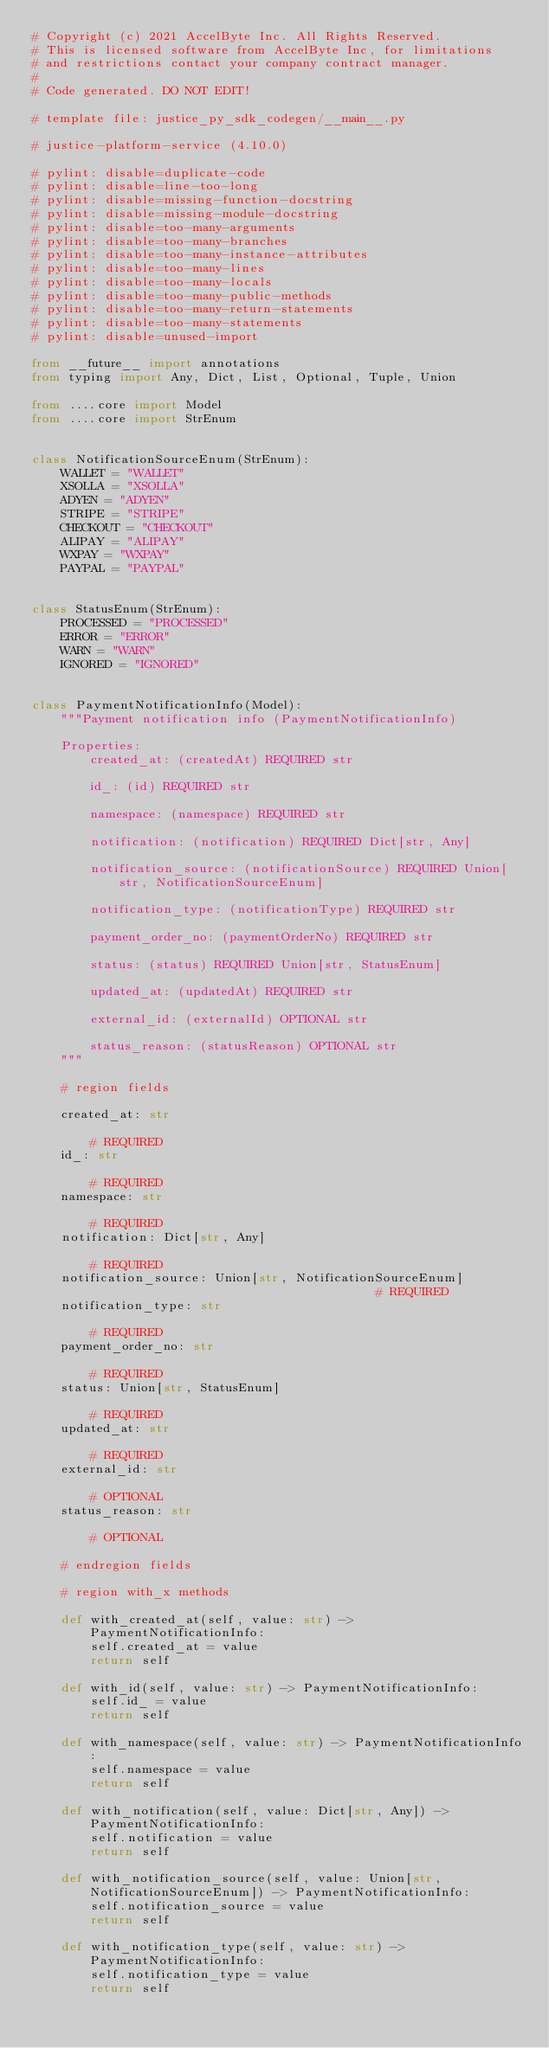Convert code to text. <code><loc_0><loc_0><loc_500><loc_500><_Python_># Copyright (c) 2021 AccelByte Inc. All Rights Reserved.
# This is licensed software from AccelByte Inc, for limitations
# and restrictions contact your company contract manager.
# 
# Code generated. DO NOT EDIT!

# template file: justice_py_sdk_codegen/__main__.py

# justice-platform-service (4.10.0)

# pylint: disable=duplicate-code
# pylint: disable=line-too-long
# pylint: disable=missing-function-docstring
# pylint: disable=missing-module-docstring
# pylint: disable=too-many-arguments
# pylint: disable=too-many-branches
# pylint: disable=too-many-instance-attributes
# pylint: disable=too-many-lines
# pylint: disable=too-many-locals
# pylint: disable=too-many-public-methods
# pylint: disable=too-many-return-statements
# pylint: disable=too-many-statements
# pylint: disable=unused-import

from __future__ import annotations
from typing import Any, Dict, List, Optional, Tuple, Union

from ....core import Model
from ....core import StrEnum


class NotificationSourceEnum(StrEnum):
    WALLET = "WALLET"
    XSOLLA = "XSOLLA"
    ADYEN = "ADYEN"
    STRIPE = "STRIPE"
    CHECKOUT = "CHECKOUT"
    ALIPAY = "ALIPAY"
    WXPAY = "WXPAY"
    PAYPAL = "PAYPAL"


class StatusEnum(StrEnum):
    PROCESSED = "PROCESSED"
    ERROR = "ERROR"
    WARN = "WARN"
    IGNORED = "IGNORED"


class PaymentNotificationInfo(Model):
    """Payment notification info (PaymentNotificationInfo)

    Properties:
        created_at: (createdAt) REQUIRED str

        id_: (id) REQUIRED str

        namespace: (namespace) REQUIRED str

        notification: (notification) REQUIRED Dict[str, Any]

        notification_source: (notificationSource) REQUIRED Union[str, NotificationSourceEnum]

        notification_type: (notificationType) REQUIRED str

        payment_order_no: (paymentOrderNo) REQUIRED str

        status: (status) REQUIRED Union[str, StatusEnum]

        updated_at: (updatedAt) REQUIRED str

        external_id: (externalId) OPTIONAL str

        status_reason: (statusReason) OPTIONAL str
    """

    # region fields

    created_at: str                                                                                # REQUIRED
    id_: str                                                                                       # REQUIRED
    namespace: str                                                                                 # REQUIRED
    notification: Dict[str, Any]                                                                   # REQUIRED
    notification_source: Union[str, NotificationSourceEnum]                                        # REQUIRED
    notification_type: str                                                                         # REQUIRED
    payment_order_no: str                                                                          # REQUIRED
    status: Union[str, StatusEnum]                                                                 # REQUIRED
    updated_at: str                                                                                # REQUIRED
    external_id: str                                                                               # OPTIONAL
    status_reason: str                                                                             # OPTIONAL

    # endregion fields

    # region with_x methods

    def with_created_at(self, value: str) -> PaymentNotificationInfo:
        self.created_at = value
        return self

    def with_id(self, value: str) -> PaymentNotificationInfo:
        self.id_ = value
        return self

    def with_namespace(self, value: str) -> PaymentNotificationInfo:
        self.namespace = value
        return self

    def with_notification(self, value: Dict[str, Any]) -> PaymentNotificationInfo:
        self.notification = value
        return self

    def with_notification_source(self, value: Union[str, NotificationSourceEnum]) -> PaymentNotificationInfo:
        self.notification_source = value
        return self

    def with_notification_type(self, value: str) -> PaymentNotificationInfo:
        self.notification_type = value
        return self
</code> 